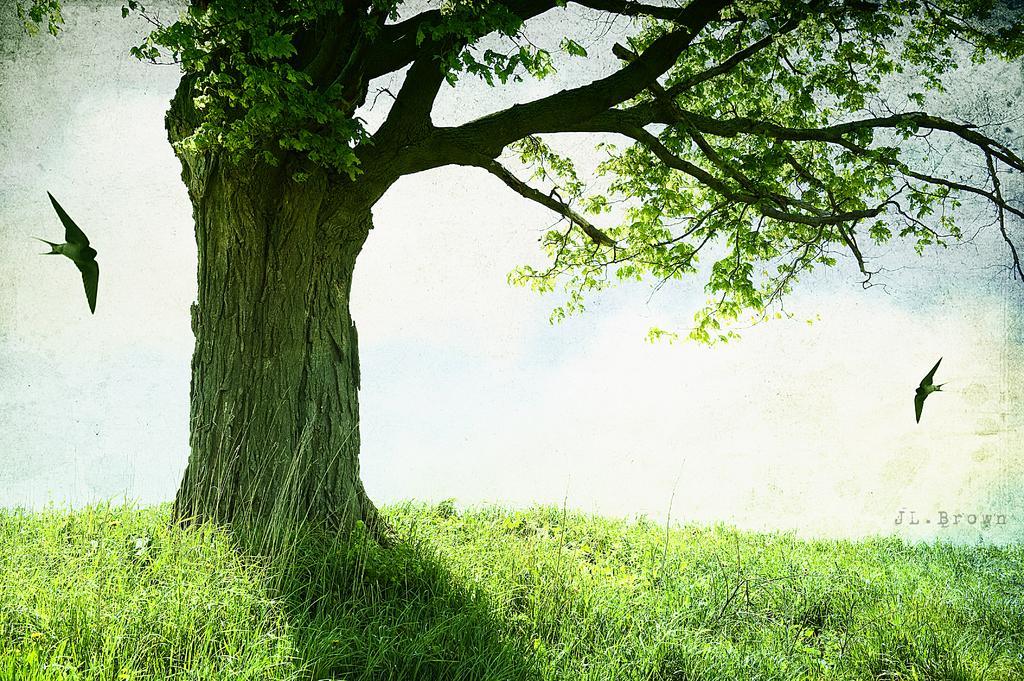Could you give a brief overview of what you see in this image? In this image there is a tree, grass, birds and the sky. 